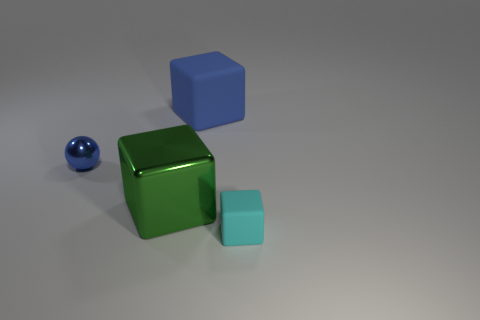Add 2 big rubber objects. How many objects exist? 6 Subtract all spheres. How many objects are left? 3 Add 2 yellow metal cylinders. How many yellow metal cylinders exist? 2 Subtract 0 gray spheres. How many objects are left? 4 Subtract all metallic balls. Subtract all blue spheres. How many objects are left? 2 Add 3 large green things. How many large green things are left? 4 